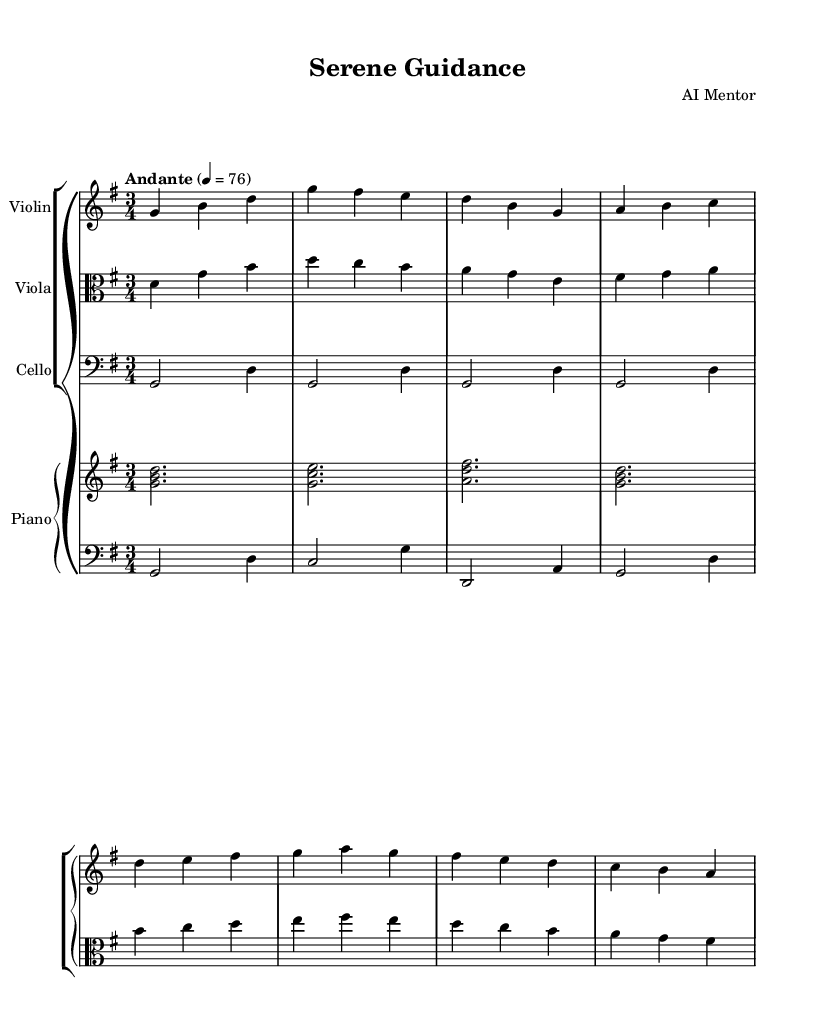What is the key signature of this music? The key signature of G major is represented by one sharp, which is F#. This is indicated at the beginning of the music sheet with a sharp sign placed on the fourth line of the staff.
Answer: G major What is the time signature of the piece? The time signature is found at the beginning of the score, displayed as a fraction. In this case, it is 3/4, indicating three beats per measure, with the quarter note receiving one beat.
Answer: 3/4 What is the tempo marking of this composition? The tempo marking is placed above the staff and typically indicates the speed of the music. Here, it is listed as "Andante," which denotes a moderate walking pace, followed by the metronome mark of 76 beats per minute.
Answer: Andante 4 = 76 How many measures are in the piece? To find the number of measures, we need to count the vertical lines that separate the musical phrases, which represent the measures. By counting these lines, we see that the music consists of eight measures in total.
Answer: 8 What instruments are included in the score? The instruments are specified at the top of each staff, identifying what each line represents. In this score, we have violin, viola, cello, and piano. Thus, the ensemble includes these four instruments.
Answer: Violin, Viola, Cello, Piano What is the dynamic marking used in the music? The dynamic markings indicate the volume of the music throughout the piece. In this score, there are no explicit dynamic markings displayed, signaling a more subdued or gentle approach to the performance.
Answer: None 